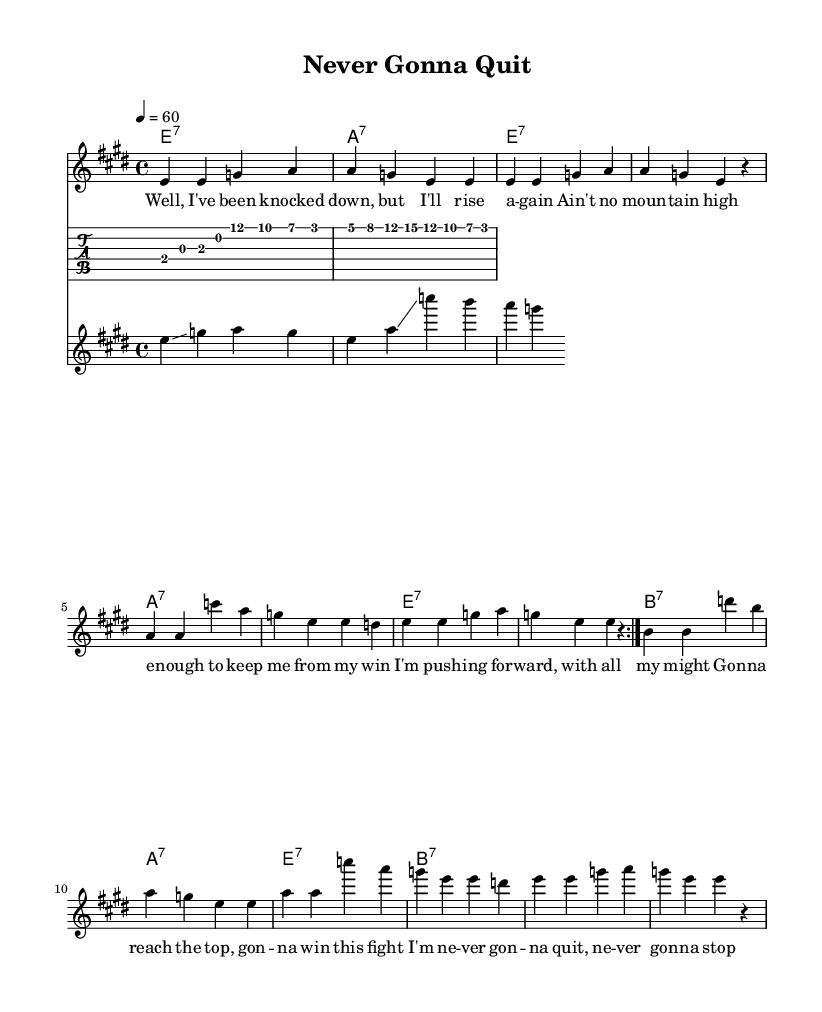What is the key signature of this music? The key signature is E major, which has four sharps: F sharp, C sharp, G sharp, and D sharp.
Answer: E major What is the time signature of this music? The time signature shown in the music is 4/4, indicating four beats per measure.
Answer: 4/4 What is the tempo marking in the sheet music? The tempo marking states 4 = 60, which indicates that a quarter note is played at a speed of 60 beats per minute.
Answer: 60 How many measures are in the verse melody? Counting the measures in the melody, there are a total of 12 measures in the verse section before it repeats.
Answer: 12 What type of chord progression is predominantly used in this Delta blues piece? The chord progression primarily used follows the standard 12-bar blues structure that cycles through the I, IV, and V chords.
Answer: 12-bar blues What is the main theme conveyed in the lyrics? The main theme in the lyrics is determined perseverance, emphasizing the resolve to not give up despite challenges.
Answer: Perseverance What instrument is used for the slide guitar part? The notation shows a separate staff labeled "slide," indicating that the slide guitar is specifically highlighted in this section.
Answer: Slide guitar 